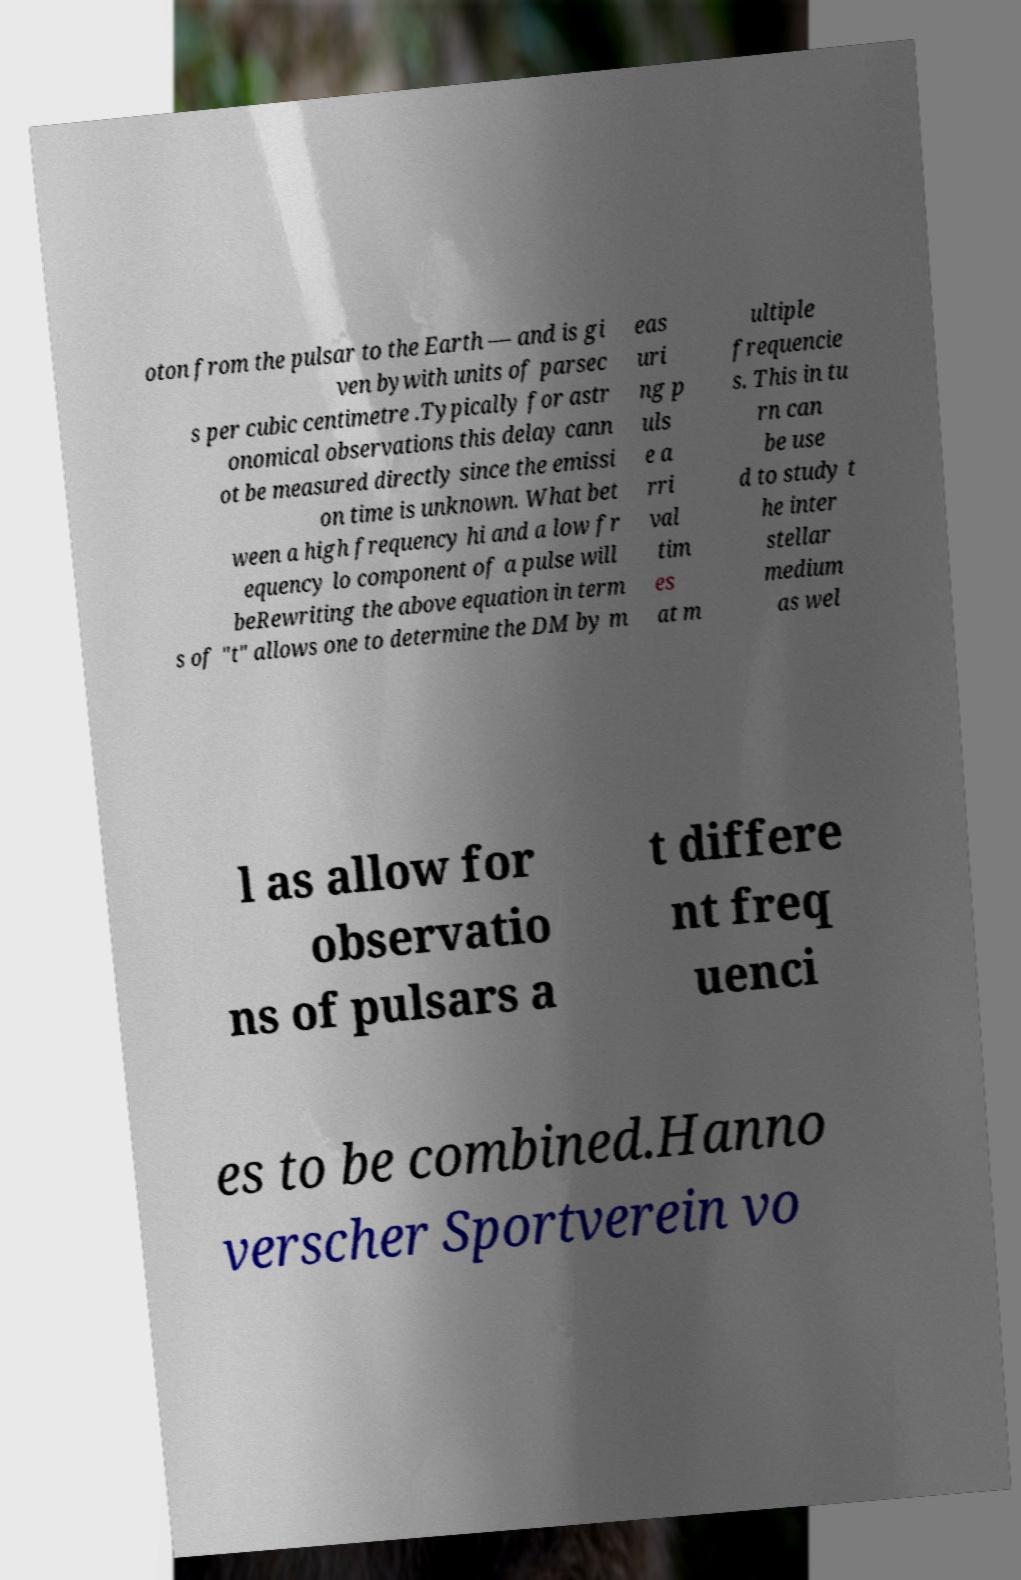Could you assist in decoding the text presented in this image and type it out clearly? oton from the pulsar to the Earth — and is gi ven bywith units of parsec s per cubic centimetre .Typically for astr onomical observations this delay cann ot be measured directly since the emissi on time is unknown. What bet ween a high frequency hi and a low fr equency lo component of a pulse will beRewriting the above equation in term s of "t" allows one to determine the DM by m eas uri ng p uls e a rri val tim es at m ultiple frequencie s. This in tu rn can be use d to study t he inter stellar medium as wel l as allow for observatio ns of pulsars a t differe nt freq uenci es to be combined.Hanno verscher Sportverein vo 